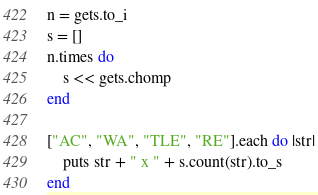<code> <loc_0><loc_0><loc_500><loc_500><_Ruby_>n = gets.to_i
s = []
n.times do
    s << gets.chomp
end

["AC", "WA", "TLE", "RE"].each do |str|
    puts str + " x " + s.count(str).to_s
end
</code> 